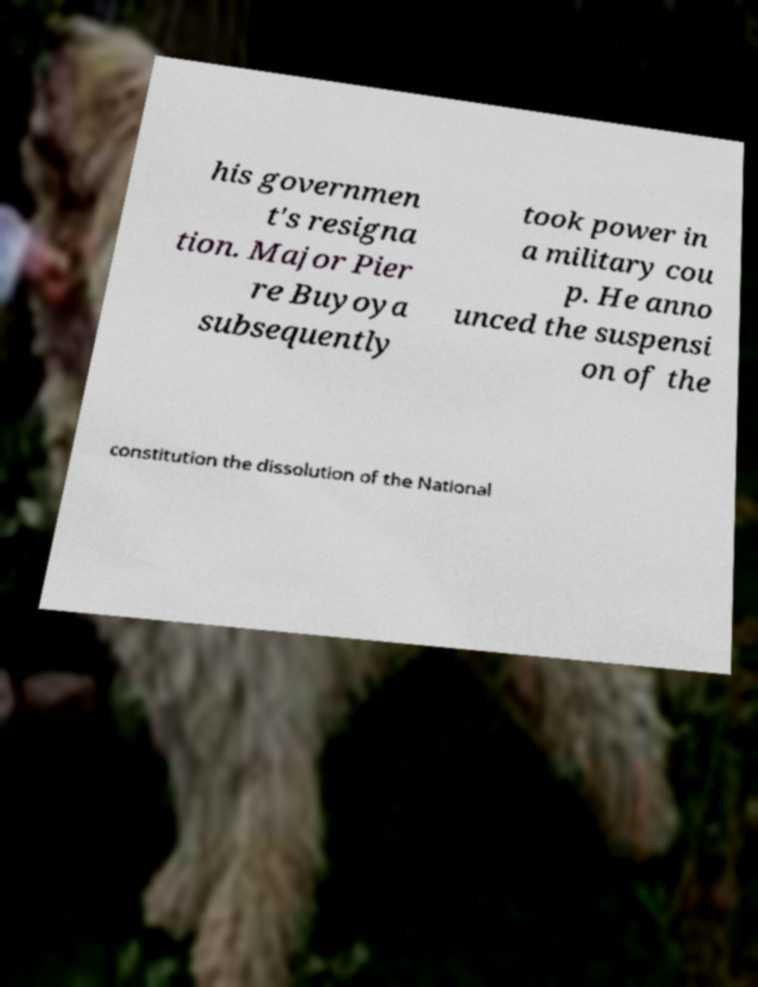For documentation purposes, I need the text within this image transcribed. Could you provide that? his governmen t's resigna tion. Major Pier re Buyoya subsequently took power in a military cou p. He anno unced the suspensi on of the constitution the dissolution of the National 